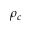<formula> <loc_0><loc_0><loc_500><loc_500>\rho _ { c }</formula> 